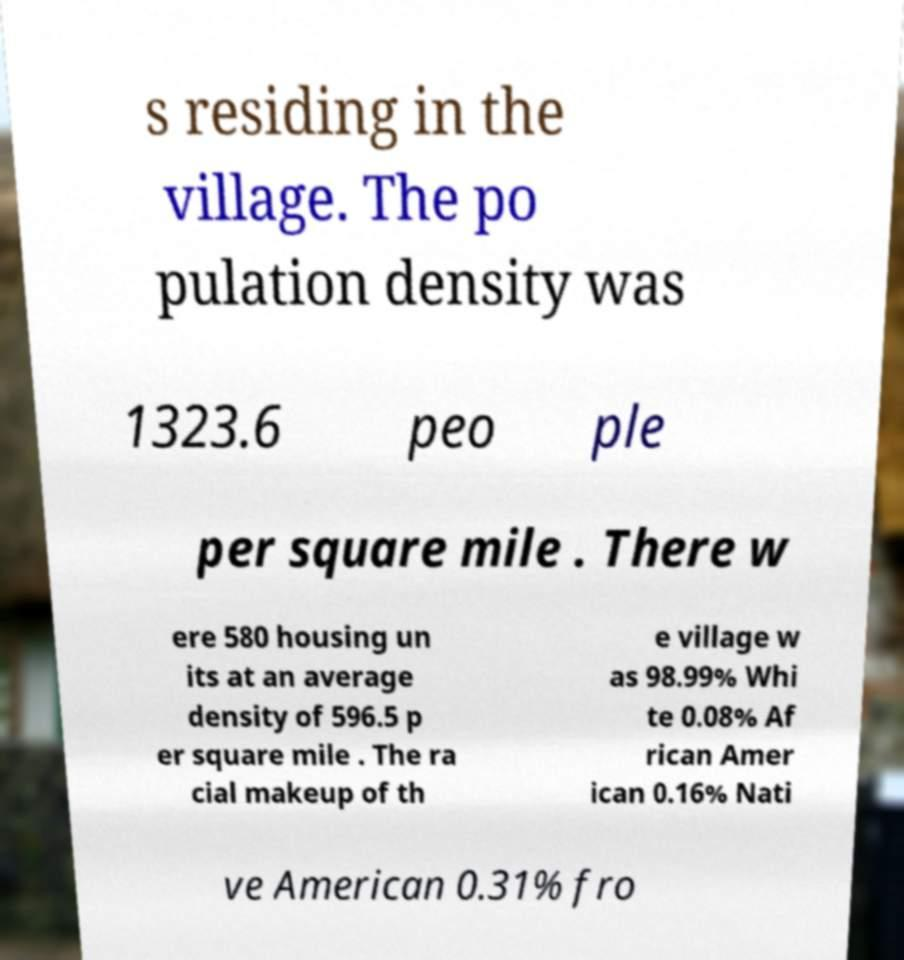Can you read and provide the text displayed in the image?This photo seems to have some interesting text. Can you extract and type it out for me? s residing in the village. The po pulation density was 1323.6 peo ple per square mile . There w ere 580 housing un its at an average density of 596.5 p er square mile . The ra cial makeup of th e village w as 98.99% Whi te 0.08% Af rican Amer ican 0.16% Nati ve American 0.31% fro 